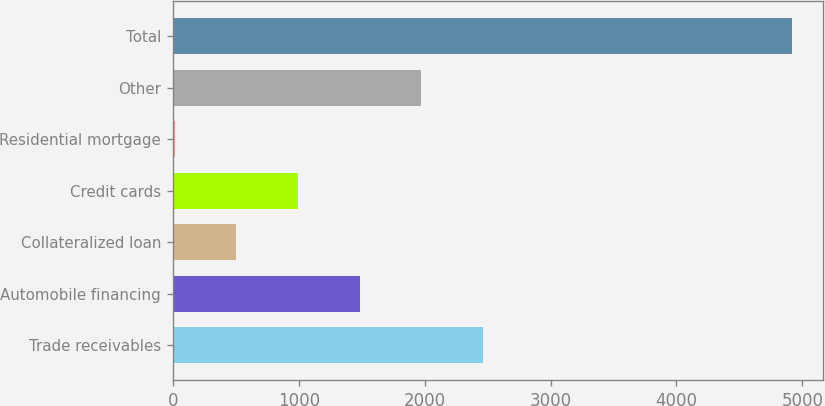Convert chart to OTSL. <chart><loc_0><loc_0><loc_500><loc_500><bar_chart><fcel>Trade receivables<fcel>Automobile financing<fcel>Collateralized loan<fcel>Credit cards<fcel>Residential mortgage<fcel>Other<fcel>Total<nl><fcel>2465<fcel>1484.6<fcel>504.2<fcel>994.4<fcel>14<fcel>1974.8<fcel>4916<nl></chart> 